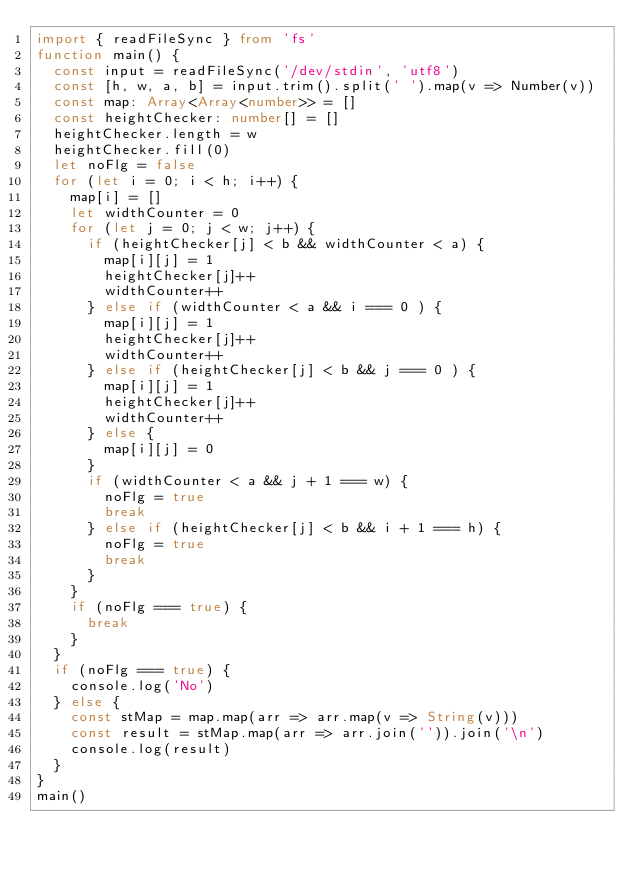<code> <loc_0><loc_0><loc_500><loc_500><_TypeScript_>import { readFileSync } from 'fs'
function main() {
  const input = readFileSync('/dev/stdin', 'utf8')
  const [h, w, a, b] = input.trim().split(' ').map(v => Number(v))
  const map: Array<Array<number>> = []
  const heightChecker: number[] = []
  heightChecker.length = w
  heightChecker.fill(0)
  let noFlg = false
  for (let i = 0; i < h; i++) {
    map[i] = []
    let widthCounter = 0
    for (let j = 0; j < w; j++) {
      if (heightChecker[j] < b && widthCounter < a) {
        map[i][j] = 1
        heightChecker[j]++
        widthCounter++
      } else if (widthCounter < a && i === 0 ) {
        map[i][j] = 1
        heightChecker[j]++
        widthCounter++
      } else if (heightChecker[j] < b && j === 0 ) {
        map[i][j] = 1
        heightChecker[j]++
        widthCounter++
      } else {
        map[i][j] = 0
      }
      if (widthCounter < a && j + 1 === w) {
        noFlg = true
        break
      } else if (heightChecker[j] < b && i + 1 === h) {
        noFlg = true
        break
      }
    }
    if (noFlg === true) {
      break
    }
  }
  if (noFlg === true) {
    console.log('No')
  } else {
    const stMap = map.map(arr => arr.map(v => String(v)))
    const result = stMap.map(arr => arr.join('')).join('\n')
    console.log(result)
  }
}
main()</code> 